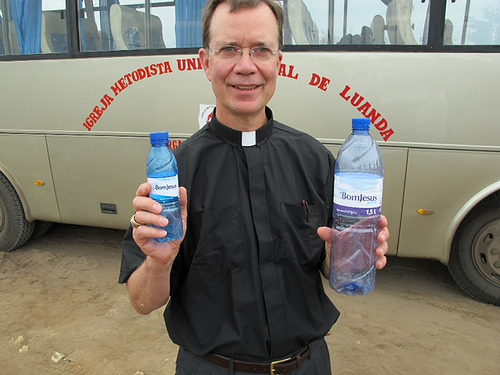<image>
Is the person in front of the bus? Yes. The person is positioned in front of the bus, appearing closer to the camera viewpoint. 